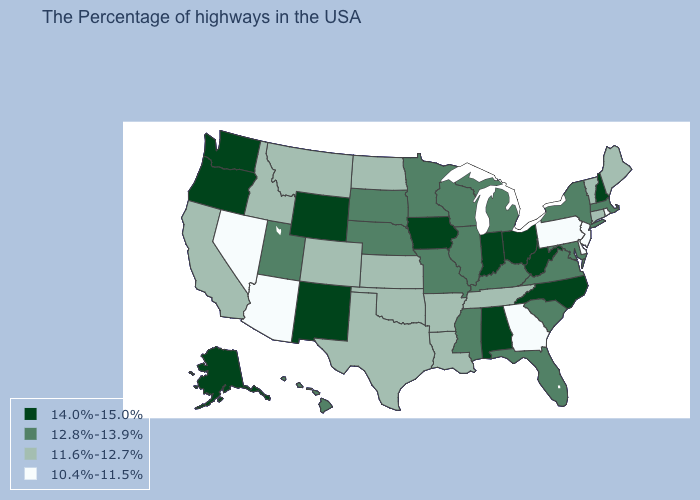Does the first symbol in the legend represent the smallest category?
Write a very short answer. No. Does Rhode Island have the lowest value in the USA?
Keep it brief. Yes. Which states have the highest value in the USA?
Quick response, please. New Hampshire, North Carolina, West Virginia, Ohio, Indiana, Alabama, Iowa, Wyoming, New Mexico, Washington, Oregon, Alaska. Which states have the lowest value in the West?
Keep it brief. Arizona, Nevada. Which states have the highest value in the USA?
Keep it brief. New Hampshire, North Carolina, West Virginia, Ohio, Indiana, Alabama, Iowa, Wyoming, New Mexico, Washington, Oregon, Alaska. What is the lowest value in the USA?
Concise answer only. 10.4%-11.5%. Name the states that have a value in the range 10.4%-11.5%?
Write a very short answer. Rhode Island, New Jersey, Delaware, Pennsylvania, Georgia, Arizona, Nevada. Does Ohio have the highest value in the USA?
Keep it brief. Yes. What is the highest value in the USA?
Be succinct. 14.0%-15.0%. What is the highest value in states that border Florida?
Be succinct. 14.0%-15.0%. What is the value of North Dakota?
Give a very brief answer. 11.6%-12.7%. What is the value of Oregon?
Short answer required. 14.0%-15.0%. What is the lowest value in the Northeast?
Be succinct. 10.4%-11.5%. Which states hav the highest value in the Northeast?
Be succinct. New Hampshire. What is the value of West Virginia?
Be succinct. 14.0%-15.0%. 